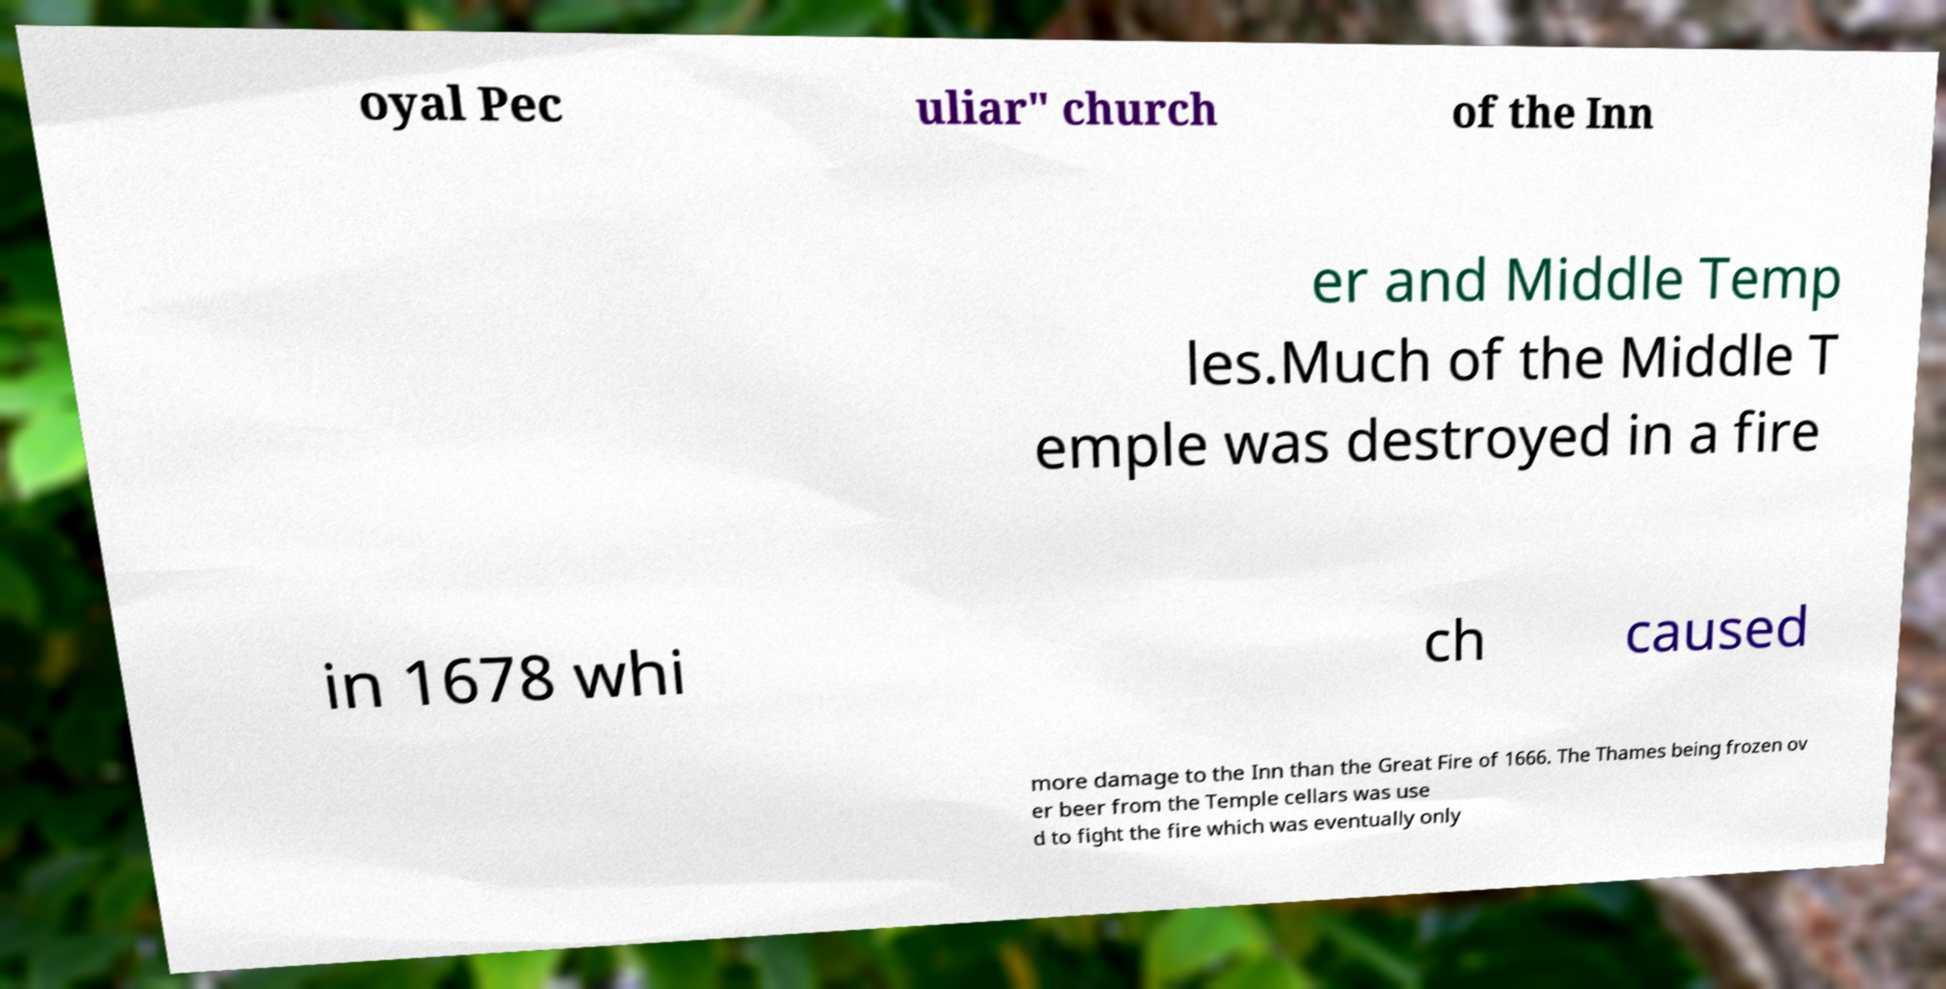I need the written content from this picture converted into text. Can you do that? oyal Pec uliar" church of the Inn er and Middle Temp les.Much of the Middle T emple was destroyed in a fire in 1678 whi ch caused more damage to the Inn than the Great Fire of 1666. The Thames being frozen ov er beer from the Temple cellars was use d to fight the fire which was eventually only 